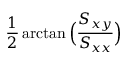<formula> <loc_0><loc_0><loc_500><loc_500>\frac { 1 } { 2 } \arctan \left ( \frac { S _ { x y } } { S _ { x x } } \right )</formula> 